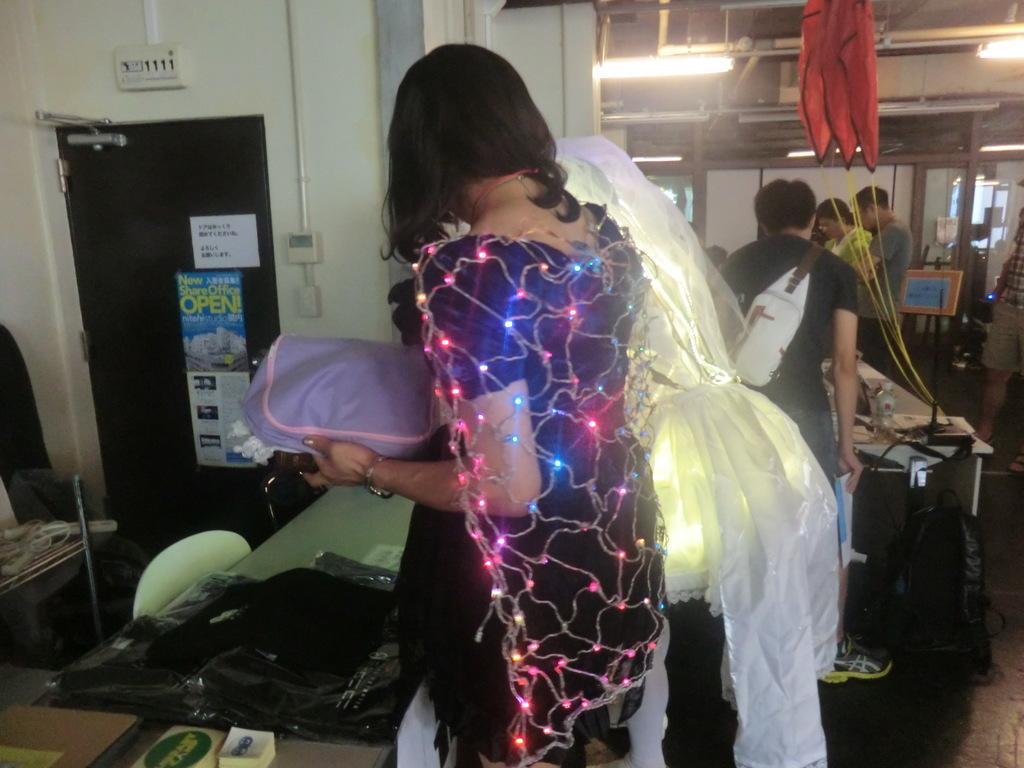Describe this image in one or two sentences. In front of the image there are two people wearing lights. In front of them there is a table. On top of it there are some objects. There is a chair. On the left side of the image there are posters on the door. At the bottom of the image there is a bag and some other objects on the floor. There are people standing on the floor. In front of the theme there is a table. On top of it there are some objects. In the background of the image there are glass windows. On top of the image there are lights and there is some object hanging. 